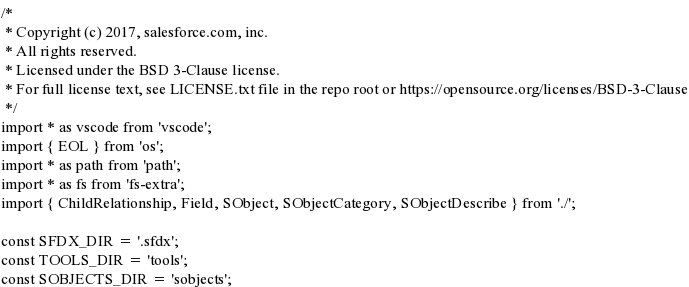<code> <loc_0><loc_0><loc_500><loc_500><_TypeScript_>/*
 * Copyright (c) 2017, salesforce.com, inc.
 * All rights reserved.
 * Licensed under the BSD 3-Clause license.
 * For full license text, see LICENSE.txt file in the repo root or https://opensource.org/licenses/BSD-3-Clause
 */
import * as vscode from 'vscode';
import { EOL } from 'os';
import * as path from 'path';
import * as fs from 'fs-extra';
import { ChildRelationship, Field, SObject, SObjectCategory, SObjectDescribe } from './';

const SFDX_DIR = '.sfdx';
const TOOLS_DIR = 'tools';
const SOBJECTS_DIR = 'sobjects';</code> 